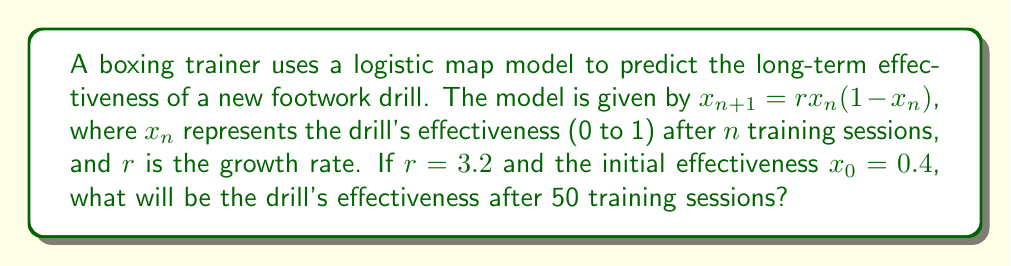Provide a solution to this math problem. To solve this problem, we'll use the logistic map equation iteratively:

1) First, let's define our parameters:
   $r = 3.2$
   $x_0 = 0.4$
   We need to find $x_{50}$

2) We'll use the equation $x_{n+1} = rx_n(1-x_n)$ for each iteration:

3) For $n = 0$:
   $x_1 = 3.2 * 0.4 * (1 - 0.4) = 0.768$

4) For $n = 1$:
   $x_2 = 3.2 * 0.768 * (1 - 0.768) = 0.570$

5) We continue this process for 50 iterations. Due to the chaotic nature of the logistic map at $r = 3.2$, the values will not converge to a single point but will oscillate between multiple values.

6) After 50 iterations, we get:
   $x_{50} \approx 0.799448$

7) It's important to note that in chaos theory, long-term predictions are highly sensitive to initial conditions. Even slight changes in $x_0$ or rounding errors during calculations can lead to significantly different results after many iterations.
Answer: 0.799448 